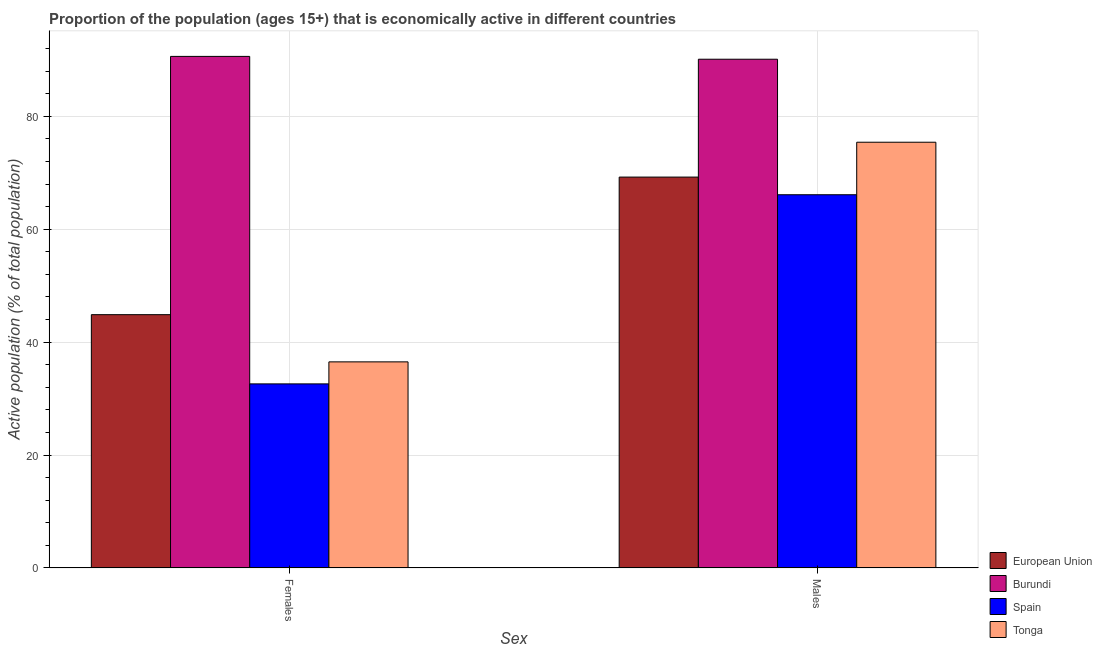How many different coloured bars are there?
Provide a succinct answer. 4. How many groups of bars are there?
Keep it short and to the point. 2. Are the number of bars per tick equal to the number of legend labels?
Your answer should be compact. Yes. How many bars are there on the 2nd tick from the left?
Your response must be concise. 4. What is the label of the 2nd group of bars from the left?
Offer a very short reply. Males. What is the percentage of economically active male population in Burundi?
Give a very brief answer. 90.1. Across all countries, what is the maximum percentage of economically active male population?
Your answer should be compact. 90.1. Across all countries, what is the minimum percentage of economically active male population?
Your answer should be compact. 66.1. In which country was the percentage of economically active female population maximum?
Your response must be concise. Burundi. In which country was the percentage of economically active female population minimum?
Your response must be concise. Spain. What is the total percentage of economically active male population in the graph?
Give a very brief answer. 300.82. What is the difference between the percentage of economically active female population in Burundi and the percentage of economically active male population in Tonga?
Provide a short and direct response. 15.2. What is the average percentage of economically active female population per country?
Your answer should be compact. 51.14. What is the ratio of the percentage of economically active female population in Tonga to that in European Union?
Offer a terse response. 0.81. What does the 3rd bar from the right in Males represents?
Give a very brief answer. Burundi. Are all the bars in the graph horizontal?
Your response must be concise. No. How many countries are there in the graph?
Provide a succinct answer. 4. Are the values on the major ticks of Y-axis written in scientific E-notation?
Make the answer very short. No. Does the graph contain grids?
Offer a terse response. Yes. How many legend labels are there?
Offer a terse response. 4. What is the title of the graph?
Provide a succinct answer. Proportion of the population (ages 15+) that is economically active in different countries. What is the label or title of the X-axis?
Provide a short and direct response. Sex. What is the label or title of the Y-axis?
Give a very brief answer. Active population (% of total population). What is the Active population (% of total population) in European Union in Females?
Keep it short and to the point. 44.86. What is the Active population (% of total population) of Burundi in Females?
Make the answer very short. 90.6. What is the Active population (% of total population) in Spain in Females?
Provide a short and direct response. 32.6. What is the Active population (% of total population) in Tonga in Females?
Ensure brevity in your answer.  36.5. What is the Active population (% of total population) in European Union in Males?
Ensure brevity in your answer.  69.22. What is the Active population (% of total population) of Burundi in Males?
Offer a very short reply. 90.1. What is the Active population (% of total population) in Spain in Males?
Ensure brevity in your answer.  66.1. What is the Active population (% of total population) in Tonga in Males?
Provide a short and direct response. 75.4. Across all Sex, what is the maximum Active population (% of total population) in European Union?
Your answer should be compact. 69.22. Across all Sex, what is the maximum Active population (% of total population) in Burundi?
Ensure brevity in your answer.  90.6. Across all Sex, what is the maximum Active population (% of total population) in Spain?
Give a very brief answer. 66.1. Across all Sex, what is the maximum Active population (% of total population) of Tonga?
Make the answer very short. 75.4. Across all Sex, what is the minimum Active population (% of total population) in European Union?
Offer a terse response. 44.86. Across all Sex, what is the minimum Active population (% of total population) in Burundi?
Offer a very short reply. 90.1. Across all Sex, what is the minimum Active population (% of total population) in Spain?
Your answer should be very brief. 32.6. Across all Sex, what is the minimum Active population (% of total population) in Tonga?
Make the answer very short. 36.5. What is the total Active population (% of total population) in European Union in the graph?
Keep it short and to the point. 114.09. What is the total Active population (% of total population) in Burundi in the graph?
Ensure brevity in your answer.  180.7. What is the total Active population (% of total population) in Spain in the graph?
Offer a very short reply. 98.7. What is the total Active population (% of total population) in Tonga in the graph?
Give a very brief answer. 111.9. What is the difference between the Active population (% of total population) in European Union in Females and that in Males?
Your response must be concise. -24.36. What is the difference between the Active population (% of total population) in Spain in Females and that in Males?
Make the answer very short. -33.5. What is the difference between the Active population (% of total population) in Tonga in Females and that in Males?
Offer a very short reply. -38.9. What is the difference between the Active population (% of total population) in European Union in Females and the Active population (% of total population) in Burundi in Males?
Your response must be concise. -45.24. What is the difference between the Active population (% of total population) in European Union in Females and the Active population (% of total population) in Spain in Males?
Keep it short and to the point. -21.24. What is the difference between the Active population (% of total population) in European Union in Females and the Active population (% of total population) in Tonga in Males?
Offer a terse response. -30.54. What is the difference between the Active population (% of total population) in Burundi in Females and the Active population (% of total population) in Tonga in Males?
Your answer should be very brief. 15.2. What is the difference between the Active population (% of total population) in Spain in Females and the Active population (% of total population) in Tonga in Males?
Give a very brief answer. -42.8. What is the average Active population (% of total population) in European Union per Sex?
Provide a short and direct response. 57.04. What is the average Active population (% of total population) in Burundi per Sex?
Offer a terse response. 90.35. What is the average Active population (% of total population) in Spain per Sex?
Offer a terse response. 49.35. What is the average Active population (% of total population) of Tonga per Sex?
Your answer should be compact. 55.95. What is the difference between the Active population (% of total population) in European Union and Active population (% of total population) in Burundi in Females?
Offer a very short reply. -45.74. What is the difference between the Active population (% of total population) of European Union and Active population (% of total population) of Spain in Females?
Give a very brief answer. 12.26. What is the difference between the Active population (% of total population) in European Union and Active population (% of total population) in Tonga in Females?
Offer a very short reply. 8.36. What is the difference between the Active population (% of total population) of Burundi and Active population (% of total population) of Tonga in Females?
Offer a terse response. 54.1. What is the difference between the Active population (% of total population) in European Union and Active population (% of total population) in Burundi in Males?
Your response must be concise. -20.88. What is the difference between the Active population (% of total population) of European Union and Active population (% of total population) of Spain in Males?
Your response must be concise. 3.12. What is the difference between the Active population (% of total population) of European Union and Active population (% of total population) of Tonga in Males?
Ensure brevity in your answer.  -6.17. What is the difference between the Active population (% of total population) in Burundi and Active population (% of total population) in Spain in Males?
Your answer should be compact. 24. What is the ratio of the Active population (% of total population) in European Union in Females to that in Males?
Offer a very short reply. 0.65. What is the ratio of the Active population (% of total population) of Burundi in Females to that in Males?
Your response must be concise. 1.01. What is the ratio of the Active population (% of total population) in Spain in Females to that in Males?
Keep it short and to the point. 0.49. What is the ratio of the Active population (% of total population) of Tonga in Females to that in Males?
Make the answer very short. 0.48. What is the difference between the highest and the second highest Active population (% of total population) of European Union?
Offer a very short reply. 24.36. What is the difference between the highest and the second highest Active population (% of total population) of Spain?
Make the answer very short. 33.5. What is the difference between the highest and the second highest Active population (% of total population) in Tonga?
Give a very brief answer. 38.9. What is the difference between the highest and the lowest Active population (% of total population) in European Union?
Provide a short and direct response. 24.36. What is the difference between the highest and the lowest Active population (% of total population) of Burundi?
Make the answer very short. 0.5. What is the difference between the highest and the lowest Active population (% of total population) of Spain?
Ensure brevity in your answer.  33.5. What is the difference between the highest and the lowest Active population (% of total population) in Tonga?
Ensure brevity in your answer.  38.9. 